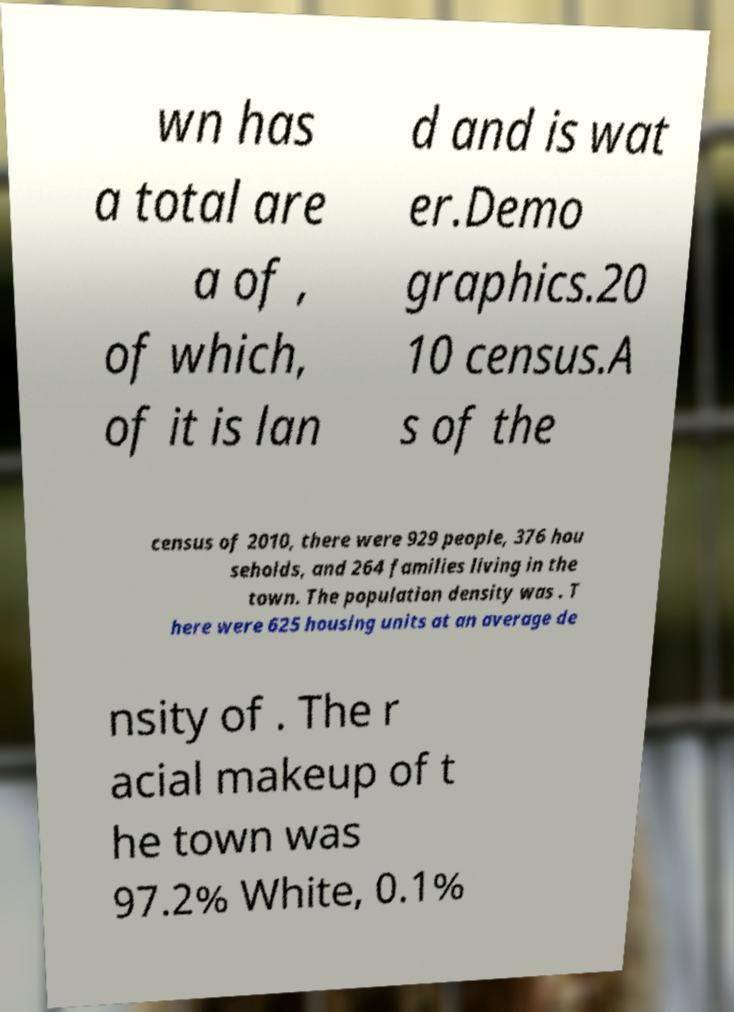Please read and relay the text visible in this image. What does it say? wn has a total are a of , of which, of it is lan d and is wat er.Demo graphics.20 10 census.A s of the census of 2010, there were 929 people, 376 hou seholds, and 264 families living in the town. The population density was . T here were 625 housing units at an average de nsity of . The r acial makeup of t he town was 97.2% White, 0.1% 